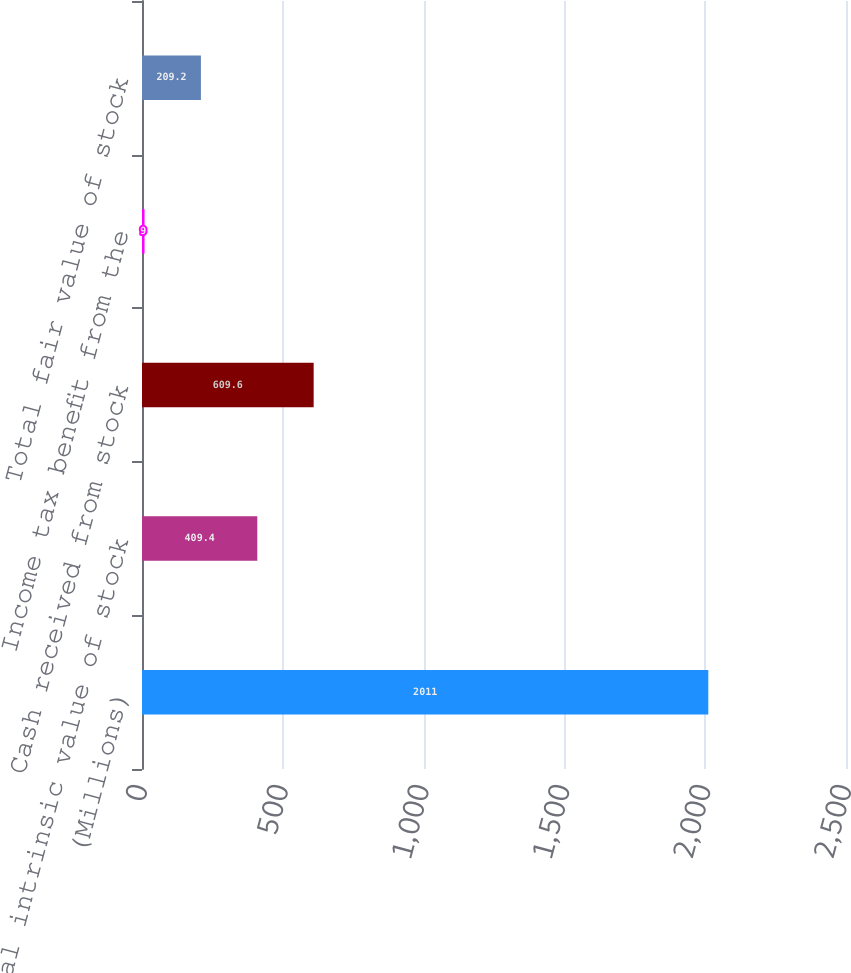Convert chart. <chart><loc_0><loc_0><loc_500><loc_500><bar_chart><fcel>(Millions)<fcel>Total intrinsic value of stock<fcel>Cash received from stock<fcel>Income tax benefit from the<fcel>Total fair value of stock<nl><fcel>2011<fcel>409.4<fcel>609.6<fcel>9<fcel>209.2<nl></chart> 